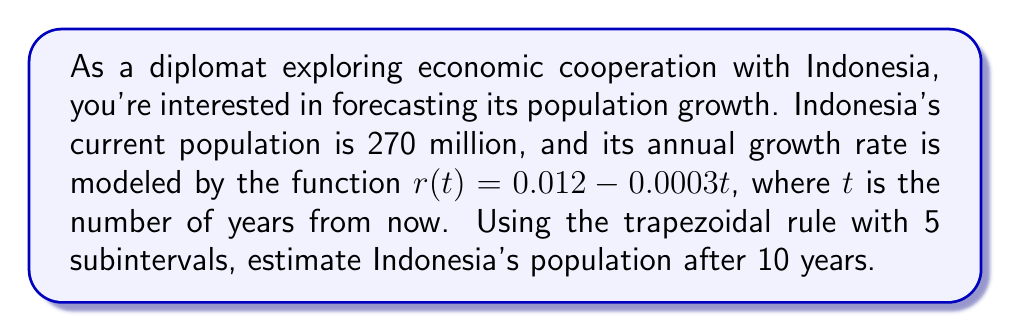Teach me how to tackle this problem. To solve this problem, we'll use numerical integration, specifically the trapezoidal rule, to estimate the population growth over 10 years.

1) The population growth can be modeled by the differential equation:
   $$\frac{dP}{dt} = r(t)P$$
   where $P$ is the population and $r(t)$ is the growth rate function.

2) Separating variables and integrating both sides:
   $$\int_{P_0}^{P} \frac{dP}{P} = \int_0^{10} r(t) dt$$
   $$\ln(\frac{P}{P_0}) = \int_0^{10} (0.012 - 0.0003t) dt$$

3) We need to estimate this integral using the trapezoidal rule with 5 subintervals. The width of each subinterval is:
   $$h = \frac{10 - 0}{5} = 2$$

4) The trapezoidal rule formula is:
   $$\int_a^b f(x) dx \approx \frac{h}{2}[f(x_0) + 2f(x_1) + 2f(x_2) + ... + 2f(x_{n-1}) + f(x_n)]$$

5) Calculating the function values:
   $f(0) = 0.012 - 0.0003(0) = 0.012$
   $f(2) = 0.012 - 0.0003(2) = 0.0114$
   $f(4) = 0.012 - 0.0003(4) = 0.0108$
   $f(6) = 0.012 - 0.0003(6) = 0.0102$
   $f(8) = 0.012 - 0.0003(8) = 0.0096$
   $f(10) = 0.012 - 0.0003(10) = 0.009$

6) Applying the trapezoidal rule:
   $$\int_0^{10} r(t) dt \approx \frac{2}{2}[0.012 + 2(0.0114) + 2(0.0108) + 2(0.0102) + 2(0.0096) + 0.009]$$
   $$= 0.1062$$

7) Therefore, $\ln(\frac{P}{P_0}) \approx 0.1062$

8) Solving for $P$:
   $$P = P_0 e^{0.1062} = 270,000,000 e^{0.1062} \approx 299,743,165$$

Thus, the estimated population after 10 years is approximately 299,743,165.
Answer: 299,743,165 people 